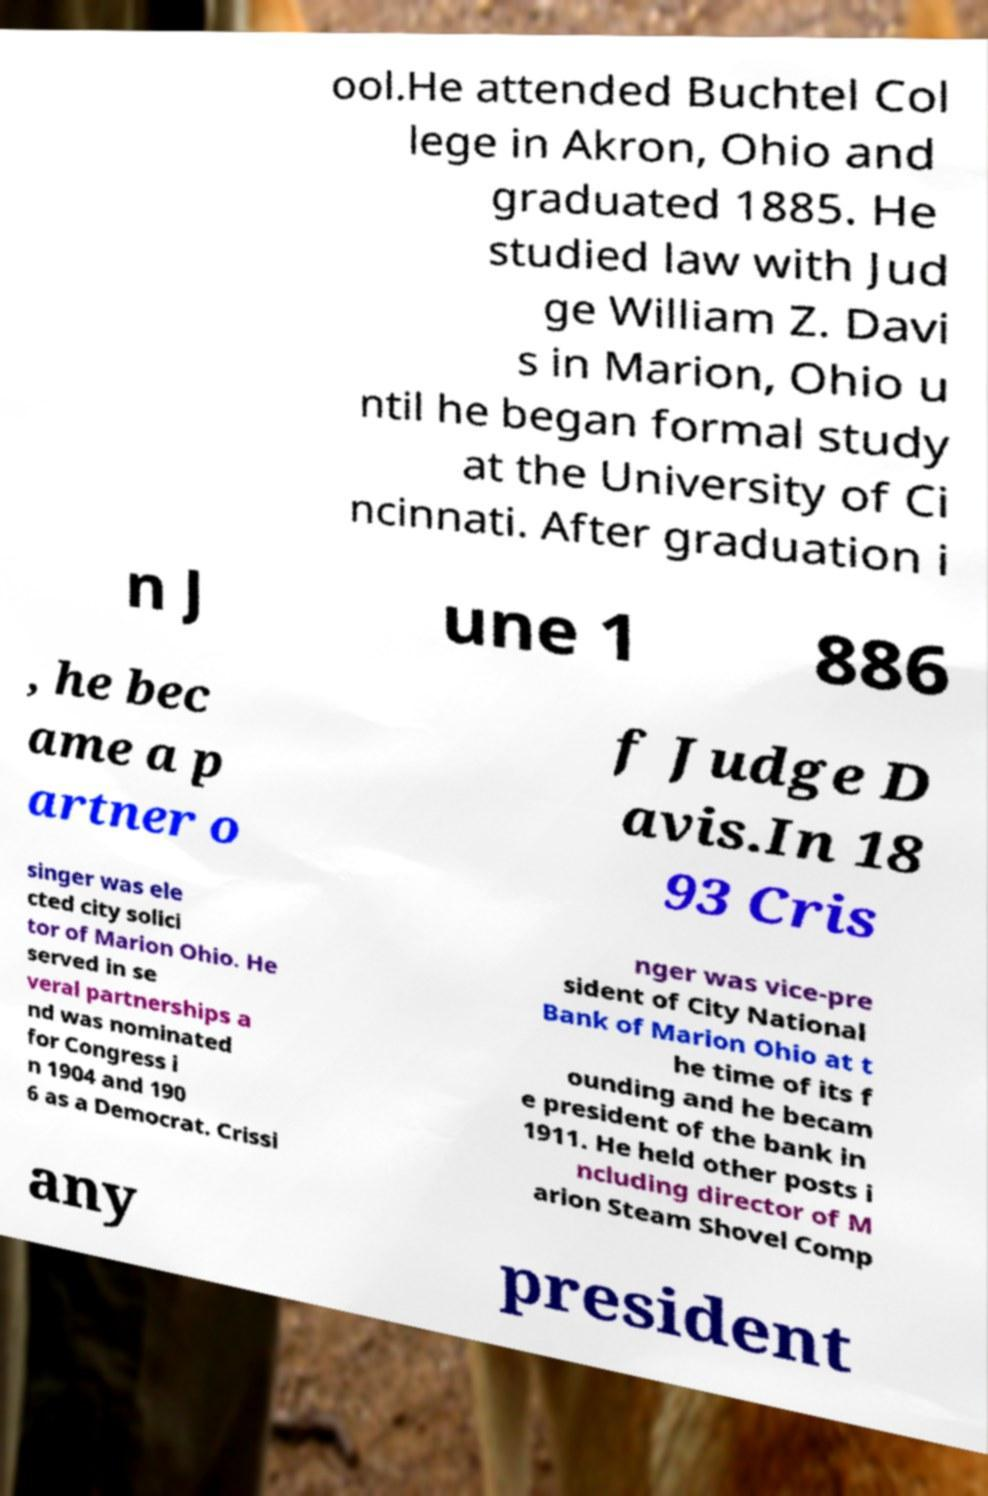Could you assist in decoding the text presented in this image and type it out clearly? ool.He attended Buchtel Col lege in Akron, Ohio and graduated 1885. He studied law with Jud ge William Z. Davi s in Marion, Ohio u ntil he began formal study at the University of Ci ncinnati. After graduation i n J une 1 886 , he bec ame a p artner o f Judge D avis.In 18 93 Cris singer was ele cted city solici tor of Marion Ohio. He served in se veral partnerships a nd was nominated for Congress i n 1904 and 190 6 as a Democrat. Crissi nger was vice-pre sident of City National Bank of Marion Ohio at t he time of its f ounding and he becam e president of the bank in 1911. He held other posts i ncluding director of M arion Steam Shovel Comp any president 